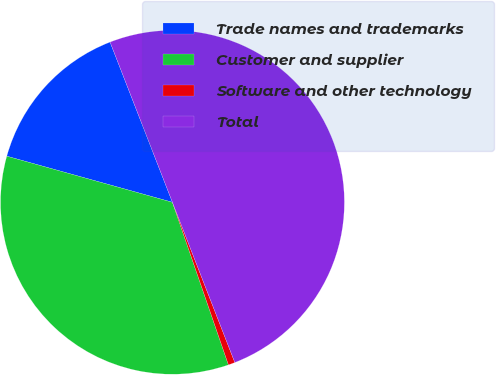Convert chart to OTSL. <chart><loc_0><loc_0><loc_500><loc_500><pie_chart><fcel>Trade names and trademarks<fcel>Customer and supplier<fcel>Software and other technology<fcel>Total<nl><fcel>14.77%<fcel>34.6%<fcel>0.63%<fcel>50.0%<nl></chart> 